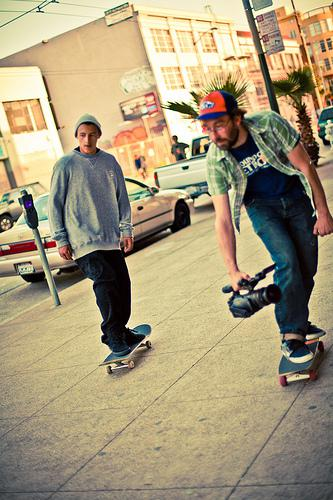Question: who is wearing a sweatshirt?
Choices:
A. The runner.
B. The skateboarder on the left.
C. The woman.
D. The man.
Answer with the letter. Answer: B Question: what activity is depicted in the photo?
Choices:
A. Skating.
B. Swimming.
C. Running.
D. Skateboarding.
Answer with the letter. Answer: D Question: when was the photo taken?
Choices:
A. Winter.
B. During the day.
C. Spring.
D. Morning.
Answer with the letter. Answer: B Question: how many vehicles are parked in the street?
Choices:
A. Three.
B. Four.
C. Two.
D. One.
Answer with the letter. Answer: B Question: what kind of trees are shown?
Choices:
A. Oaks.
B. Maples.
C. Pines.
D. Palm trees.
Answer with the letter. Answer: D Question: how many parking meters are visible?
Choices:
A. Two.
B. Three.
C. One.
D. Four.
Answer with the letter. Answer: C 